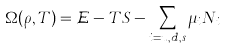Convert formula to latex. <formula><loc_0><loc_0><loc_500><loc_500>\Omega ( \rho , T ) = { \mathcal { E } } - T S - \sum _ { i = u , d , s } \mu _ { i } N _ { i } \,</formula> 